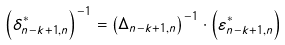Convert formula to latex. <formula><loc_0><loc_0><loc_500><loc_500>\left ( { \delta ^ { * } _ { n - k + 1 , n } } \right ) ^ { - 1 } = \left ( \Delta _ { n - k + 1 , n } \right ) ^ { - 1 } \cdot \left ( { \varepsilon ^ { * } _ { n - k + 1 , n } } \right )</formula> 